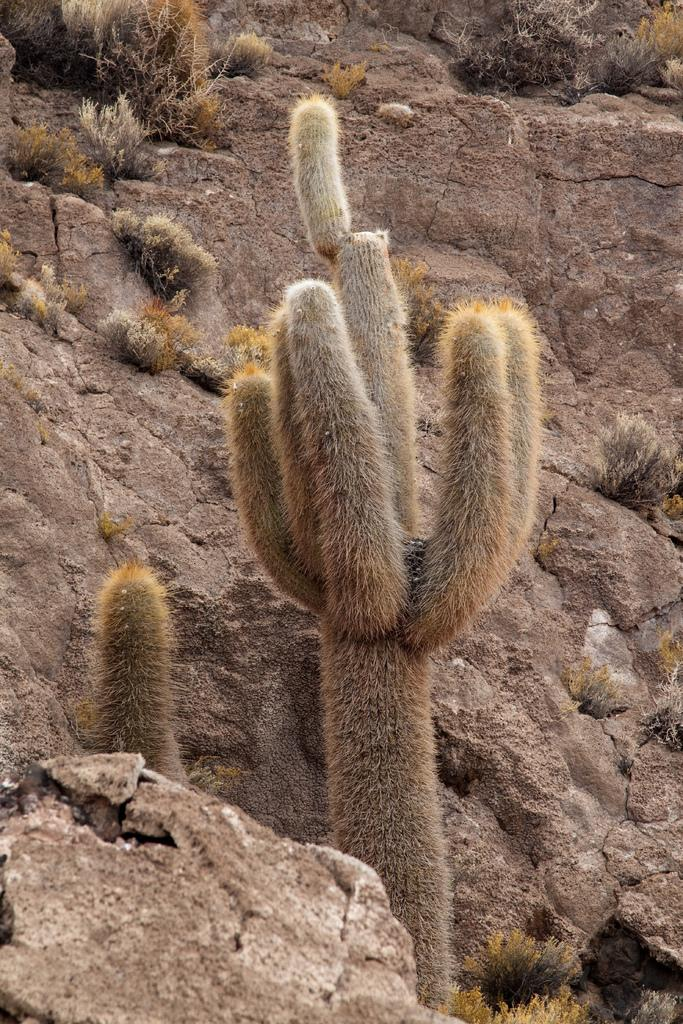Where was the picture taken? The picture was clicked outside. What type of plants can be seen in the image? There are cactus plants and other plants in the image. What other natural elements are present in the image? There are rocks in the image. Are there any man-made objects visible in the image? Yes, there are other objects in the image. What is the manager's role in the journey depicted in the image? There is no journey or manager depicted in the image; it features cactus plants, other plants, rocks, and other objects. 